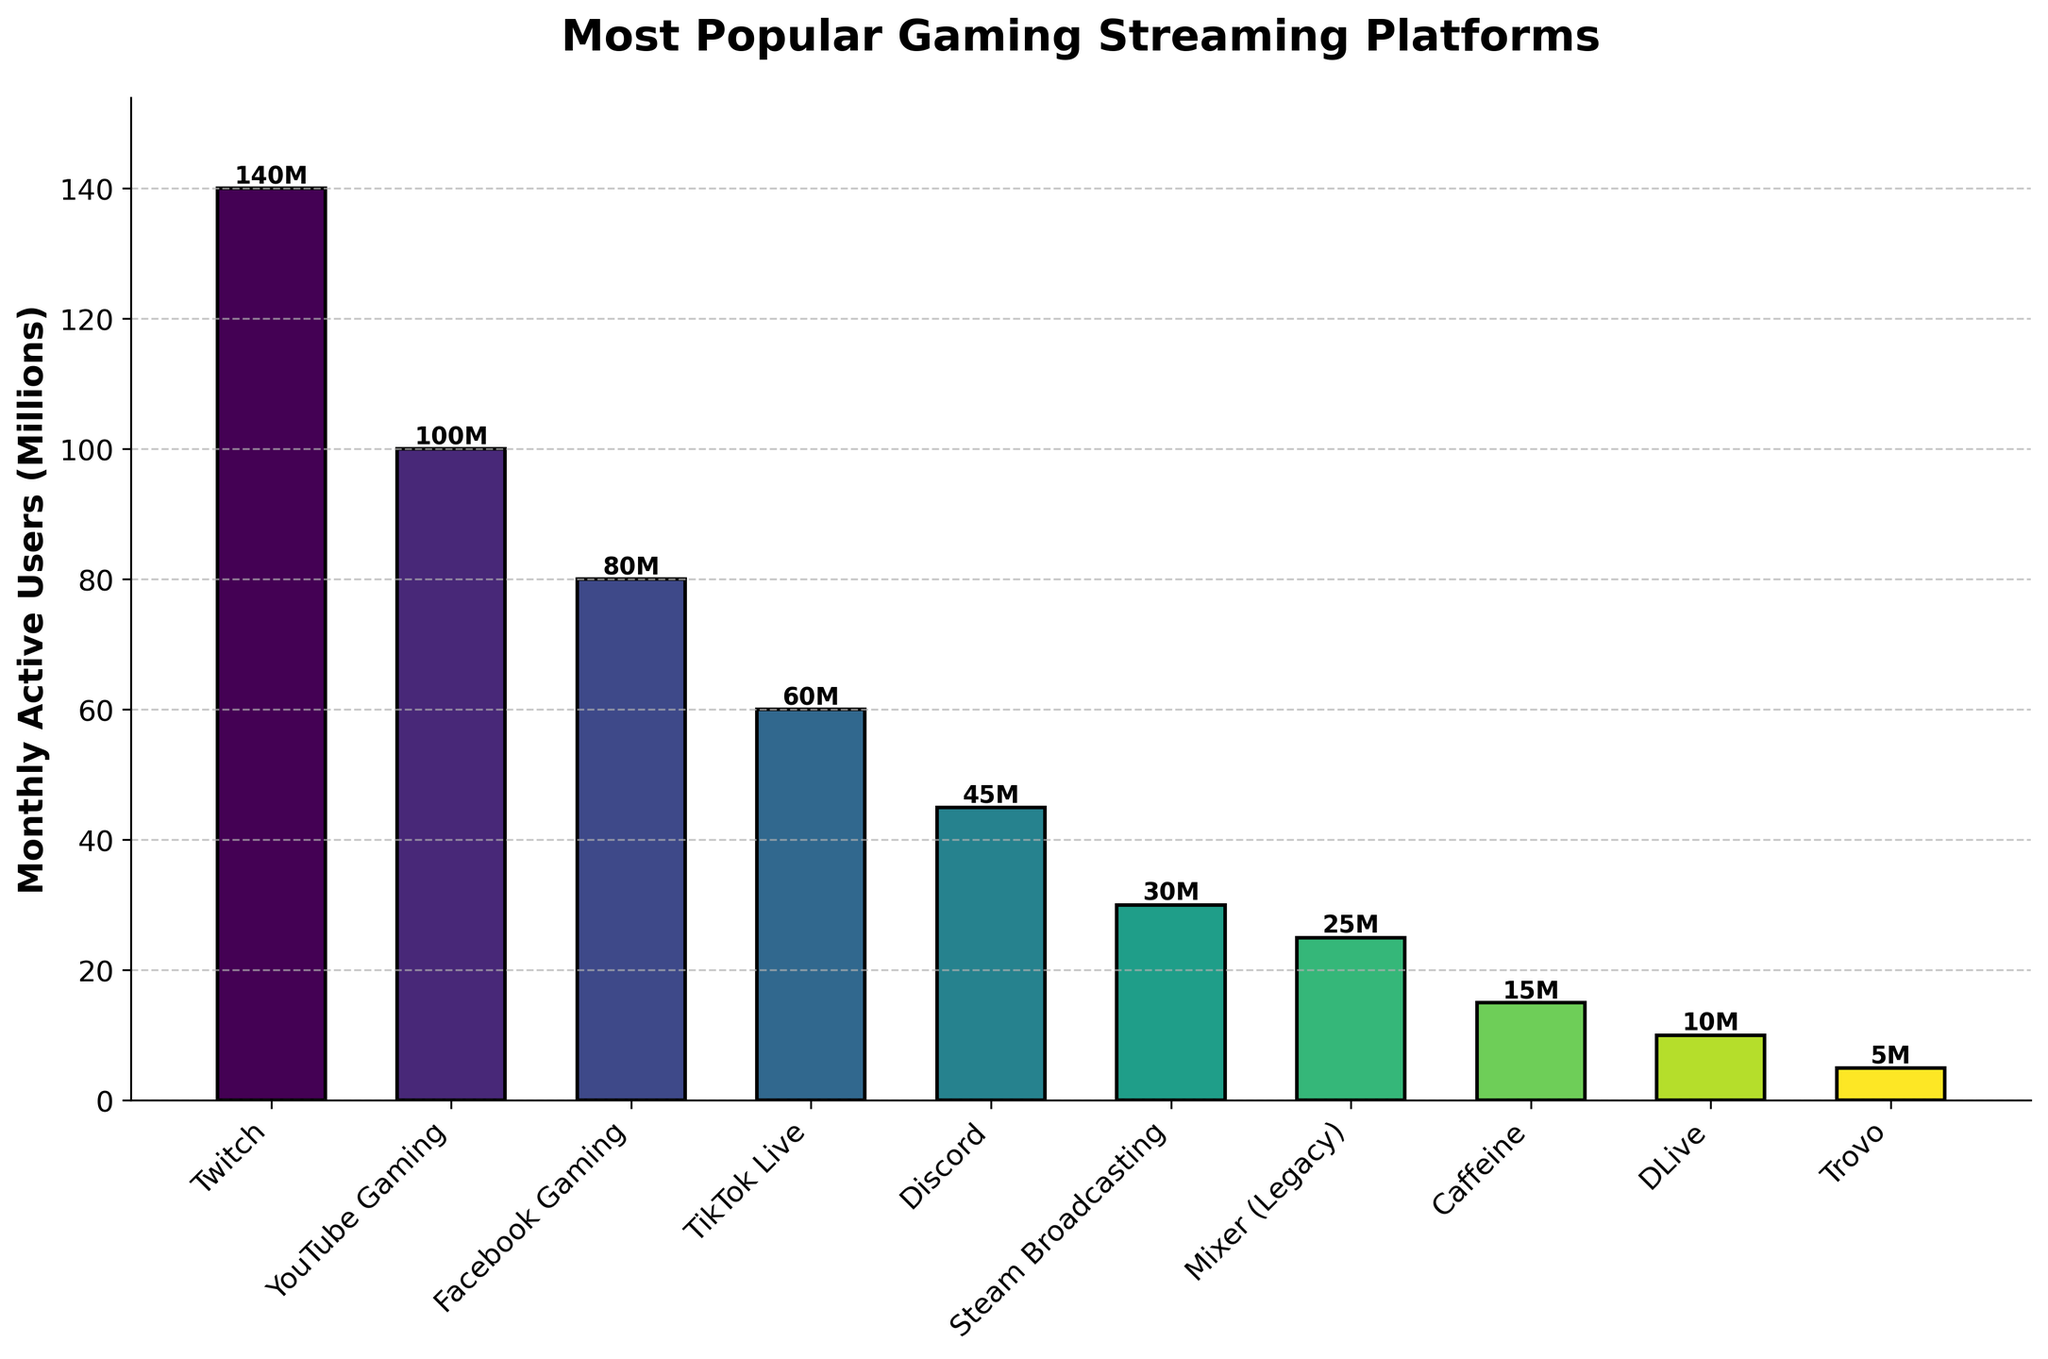Which platform has the highest number of monthly active users? The height of the bars represents the number of monthly active users. The tallest bar corresponds to Twitch with 140 million users.
Answer: Twitch Which platform has the least number of monthly active users? The shortest bar corresponds to Trovo, which has 5 million monthly active users.
Answer: Trovo How many more monthly active users does Twitch have compared to YouTube Gaming? The height of the bar for Twitch is 140 million and for YouTube Gaming is 100 million. The difference is 140 million - 100 million.
Answer: 40 million What's the combined number of monthly active users for Facebook Gaming and TikTok Live? Facebook Gaming has 80 million and TikTok Live has 60 million monthly active users. Their combined total is 80 million + 60 million.
Answer: 140 million Is Discord more popular than Steam Broadcasting in terms of monthly active users? The height of the bar for Discord is 45 million, while for Steam Broadcasting it is 30 million, so Discord has more users.
Answer: Yes Which platforms have fewer than 50 million monthly active users? Bars representing platforms with fewer than 50 million users are identified: Discord (45 million), Steam Broadcasting (30 million), Mixer (Legacy) (25 million), Caffeine (15 million), DLive (10 million), and Trovo (5 million).
Answer: Discord, Steam Broadcasting, Mixer (Legacy), Caffeine, DLive, Trovo What's the average number of monthly active users for the top three platforms? Adding the users for the top three platforms (Twitch, 140 million; YouTube Gaming, 100 million; Facebook Gaming, 80 million) gives 320 million. Dividing by 3 gives the average: 320 million / 3.
Answer: 106.67 million Which platform has exactly 25 million monthly active users? The bar for Mixer (Legacy) is at the level of 25 million monthly active users.
Answer: Mixer (Legacy) How much taller is the bar for YouTube Gaming compared to TikTok Live? The users for YouTube Gaming are 100 million, and TikTok Live are 60 million. The difference in height is 100 million - 60 million.
Answer: 40 million If you summed the monthly active users of DLive and Trovo, how many users would you get? DLive has 10 million and Trovo has 5 million monthly active users. The sum is 10 million + 5 million.
Answer: 15 million 